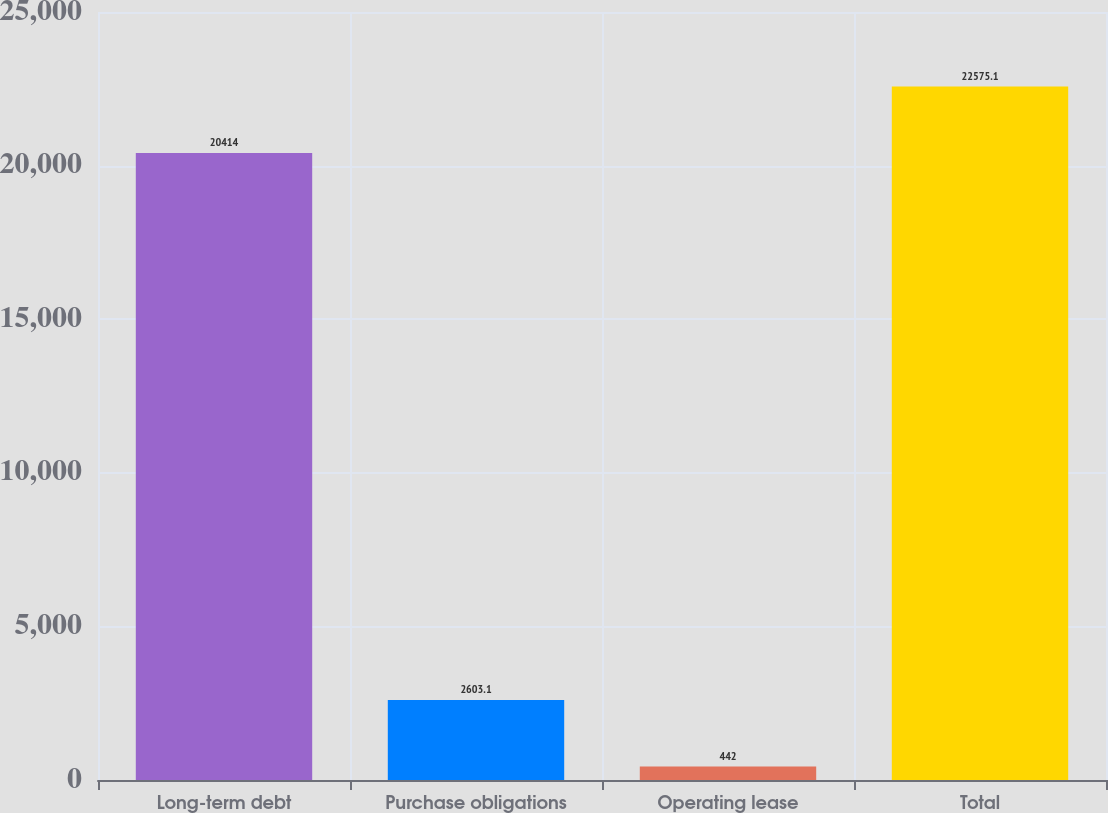Convert chart to OTSL. <chart><loc_0><loc_0><loc_500><loc_500><bar_chart><fcel>Long-term debt<fcel>Purchase obligations<fcel>Operating lease<fcel>Total<nl><fcel>20414<fcel>2603.1<fcel>442<fcel>22575.1<nl></chart> 